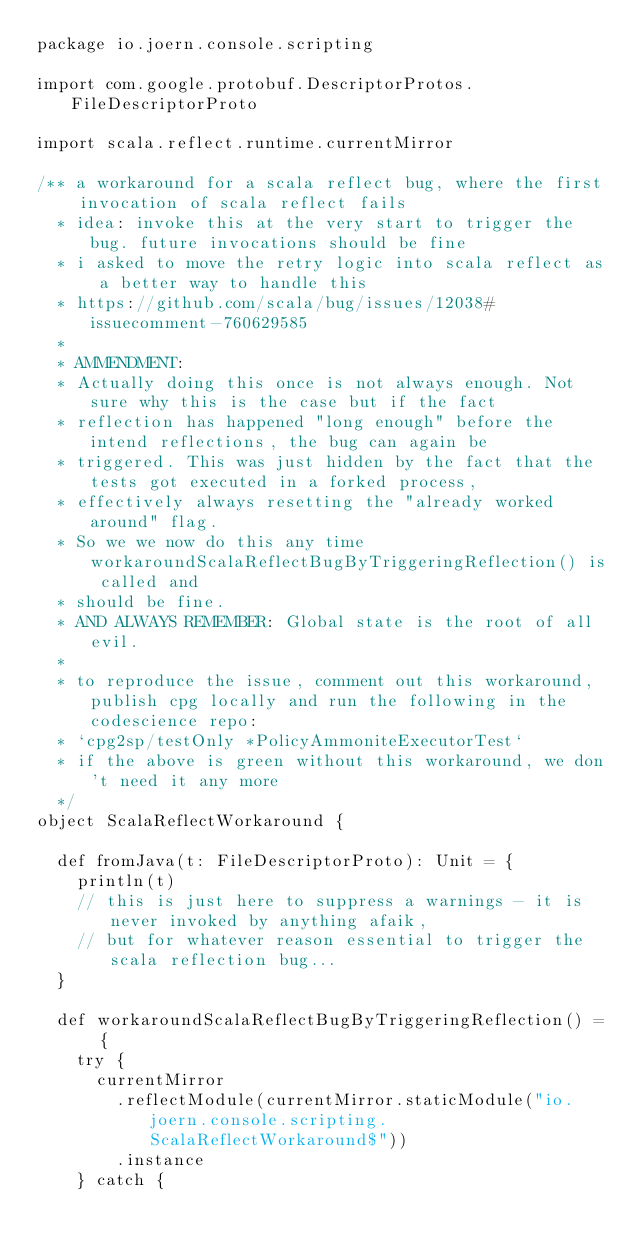Convert code to text. <code><loc_0><loc_0><loc_500><loc_500><_Scala_>package io.joern.console.scripting

import com.google.protobuf.DescriptorProtos.FileDescriptorProto

import scala.reflect.runtime.currentMirror

/** a workaround for a scala reflect bug, where the first invocation of scala reflect fails
  * idea: invoke this at the very start to trigger the bug. future invocations should be fine
  * i asked to move the retry logic into scala reflect as a better way to handle this
  * https://github.com/scala/bug/issues/12038#issuecomment-760629585
  *
  * AMMENDMENT:
  * Actually doing this once is not always enough. Not sure why this is the case but if the fact
  * reflection has happened "long enough" before the intend reflections, the bug can again be
  * triggered. This was just hidden by the fact that the tests got executed in a forked process,
  * effectively always resetting the "already worked around" flag.
  * So we we now do this any time workaroundScalaReflectBugByTriggeringReflection() is called and
  * should be fine.
  * AND ALWAYS REMEMBER: Global state is the root of all evil.
  *
  * to reproduce the issue, comment out this workaround, publish cpg locally and run the following in the codescience repo:
  * `cpg2sp/testOnly *PolicyAmmoniteExecutorTest`
  * if the above is green without this workaround, we don't need it any more
  */
object ScalaReflectWorkaround {

  def fromJava(t: FileDescriptorProto): Unit = {
    println(t)
    // this is just here to suppress a warnings - it is never invoked by anything afaik,
    // but for whatever reason essential to trigger the scala reflection bug...
  }

  def workaroundScalaReflectBugByTriggeringReflection() = {
    try {
      currentMirror
        .reflectModule(currentMirror.staticModule("io.joern.console.scripting.ScalaReflectWorkaround$"))
        .instance
    } catch {</code> 